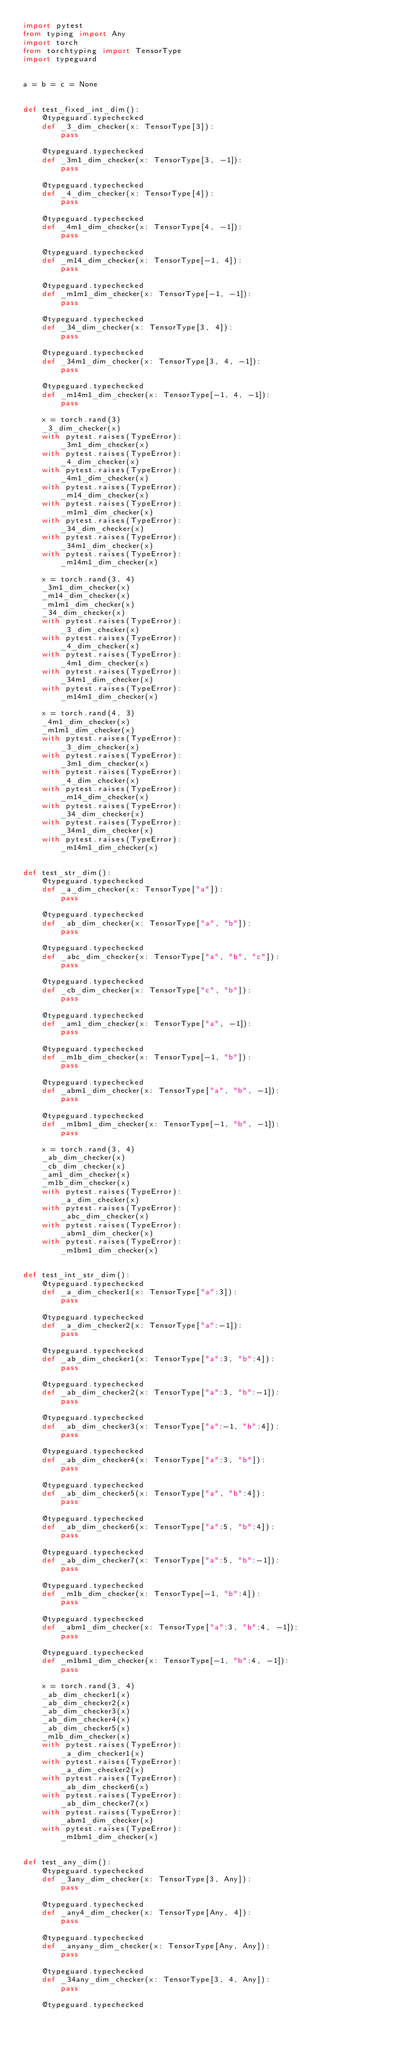<code> <loc_0><loc_0><loc_500><loc_500><_Python_>import pytest
from typing import Any
import torch
from torchtyping import TensorType
import typeguard


a = b = c = None


def test_fixed_int_dim():
    @typeguard.typechecked
    def _3_dim_checker(x: TensorType[3]):
        pass

    @typeguard.typechecked
    def _3m1_dim_checker(x: TensorType[3, -1]):
        pass

    @typeguard.typechecked
    def _4_dim_checker(x: TensorType[4]):
        pass

    @typeguard.typechecked
    def _4m1_dim_checker(x: TensorType[4, -1]):
        pass

    @typeguard.typechecked
    def _m14_dim_checker(x: TensorType[-1, 4]):
        pass

    @typeguard.typechecked
    def _m1m1_dim_checker(x: TensorType[-1, -1]):
        pass

    @typeguard.typechecked
    def _34_dim_checker(x: TensorType[3, 4]):
        pass

    @typeguard.typechecked
    def _34m1_dim_checker(x: TensorType[3, 4, -1]):
        pass

    @typeguard.typechecked
    def _m14m1_dim_checker(x: TensorType[-1, 4, -1]):
        pass

    x = torch.rand(3)
    _3_dim_checker(x)
    with pytest.raises(TypeError):
        _3m1_dim_checker(x)
    with pytest.raises(TypeError):
        _4_dim_checker(x)
    with pytest.raises(TypeError):
        _4m1_dim_checker(x)
    with pytest.raises(TypeError):
        _m14_dim_checker(x)
    with pytest.raises(TypeError):
        _m1m1_dim_checker(x)
    with pytest.raises(TypeError):
        _34_dim_checker(x)
    with pytest.raises(TypeError):
        _34m1_dim_checker(x)
    with pytest.raises(TypeError):
        _m14m1_dim_checker(x)

    x = torch.rand(3, 4)
    _3m1_dim_checker(x)
    _m14_dim_checker(x)
    _m1m1_dim_checker(x)
    _34_dim_checker(x)
    with pytest.raises(TypeError):
        _3_dim_checker(x)
    with pytest.raises(TypeError):
        _4_dim_checker(x)
    with pytest.raises(TypeError):
        _4m1_dim_checker(x)
    with pytest.raises(TypeError):
        _34m1_dim_checker(x)
    with pytest.raises(TypeError):
        _m14m1_dim_checker(x)

    x = torch.rand(4, 3)
    _4m1_dim_checker(x)
    _m1m1_dim_checker(x)
    with pytest.raises(TypeError):
        _3_dim_checker(x)
    with pytest.raises(TypeError):
        _3m1_dim_checker(x)
    with pytest.raises(TypeError):
        _4_dim_checker(x)
    with pytest.raises(TypeError):
        _m14_dim_checker(x)
    with pytest.raises(TypeError):
        _34_dim_checker(x)
    with pytest.raises(TypeError):
        _34m1_dim_checker(x)
    with pytest.raises(TypeError):
        _m14m1_dim_checker(x)


def test_str_dim():
    @typeguard.typechecked
    def _a_dim_checker(x: TensorType["a"]):
        pass

    @typeguard.typechecked
    def _ab_dim_checker(x: TensorType["a", "b"]):
        pass

    @typeguard.typechecked
    def _abc_dim_checker(x: TensorType["a", "b", "c"]):
        pass

    @typeguard.typechecked
    def _cb_dim_checker(x: TensorType["c", "b"]):
        pass

    @typeguard.typechecked
    def _am1_dim_checker(x: TensorType["a", -1]):
        pass

    @typeguard.typechecked
    def _m1b_dim_checker(x: TensorType[-1, "b"]):
        pass

    @typeguard.typechecked
    def _abm1_dim_checker(x: TensorType["a", "b", -1]):
        pass

    @typeguard.typechecked
    def _m1bm1_dim_checker(x: TensorType[-1, "b", -1]):
        pass

    x = torch.rand(3, 4)
    _ab_dim_checker(x)
    _cb_dim_checker(x)
    _am1_dim_checker(x)
    _m1b_dim_checker(x)
    with pytest.raises(TypeError):
        _a_dim_checker(x)
    with pytest.raises(TypeError):
        _abc_dim_checker(x)
    with pytest.raises(TypeError):
        _abm1_dim_checker(x)
    with pytest.raises(TypeError):
        _m1bm1_dim_checker(x)


def test_int_str_dim():
    @typeguard.typechecked
    def _a_dim_checker1(x: TensorType["a":3]):
        pass

    @typeguard.typechecked
    def _a_dim_checker2(x: TensorType["a":-1]):
        pass

    @typeguard.typechecked
    def _ab_dim_checker1(x: TensorType["a":3, "b":4]):
        pass

    @typeguard.typechecked
    def _ab_dim_checker2(x: TensorType["a":3, "b":-1]):
        pass

    @typeguard.typechecked
    def _ab_dim_checker3(x: TensorType["a":-1, "b":4]):
        pass

    @typeguard.typechecked
    def _ab_dim_checker4(x: TensorType["a":3, "b"]):
        pass

    @typeguard.typechecked
    def _ab_dim_checker5(x: TensorType["a", "b":4]):
        pass

    @typeguard.typechecked
    def _ab_dim_checker6(x: TensorType["a":5, "b":4]):
        pass

    @typeguard.typechecked
    def _ab_dim_checker7(x: TensorType["a":5, "b":-1]):
        pass

    @typeguard.typechecked
    def _m1b_dim_checker(x: TensorType[-1, "b":4]):
        pass

    @typeguard.typechecked
    def _abm1_dim_checker(x: TensorType["a":3, "b":4, -1]):
        pass

    @typeguard.typechecked
    def _m1bm1_dim_checker(x: TensorType[-1, "b":4, -1]):
        pass

    x = torch.rand(3, 4)
    _ab_dim_checker1(x)
    _ab_dim_checker2(x)
    _ab_dim_checker3(x)
    _ab_dim_checker4(x)
    _ab_dim_checker5(x)
    _m1b_dim_checker(x)
    with pytest.raises(TypeError):
        _a_dim_checker1(x)
    with pytest.raises(TypeError):
        _a_dim_checker2(x)
    with pytest.raises(TypeError):
        _ab_dim_checker6(x)
    with pytest.raises(TypeError):
        _ab_dim_checker7(x)
    with pytest.raises(TypeError):
        _abm1_dim_checker(x)
    with pytest.raises(TypeError):
        _m1bm1_dim_checker(x)


def test_any_dim():
    @typeguard.typechecked
    def _3any_dim_checker(x: TensorType[3, Any]):
        pass

    @typeguard.typechecked
    def _any4_dim_checker(x: TensorType[Any, 4]):
        pass

    @typeguard.typechecked
    def _anyany_dim_checker(x: TensorType[Any, Any]):
        pass

    @typeguard.typechecked
    def _34any_dim_checker(x: TensorType[3, 4, Any]):
        pass

    @typeguard.typechecked</code> 